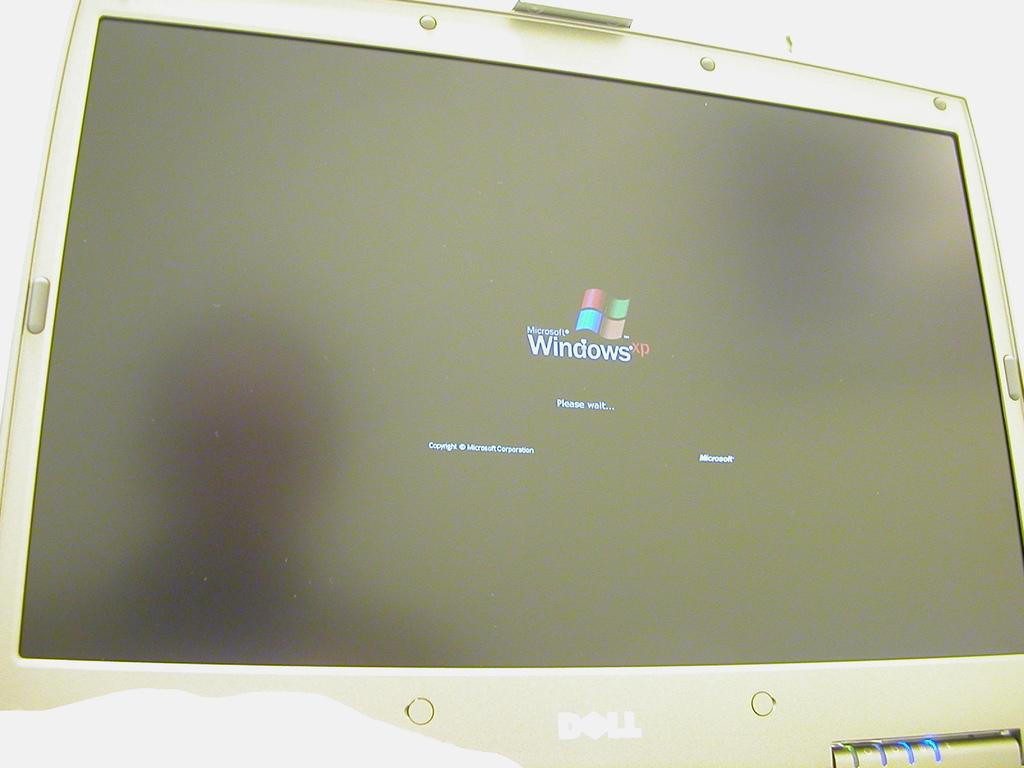What electronic device is visible in the image? There is a monitor in the image. What is displayed on the monitor screen? There is an image and text on the monitor screen. Is there any identifying information on the image displayed on the monitor? Yes, there is a name at the bottom of the image on the monitor. What type of band is performing on the shelf in the image? There is no band or shelf present in the image; it only features a monitor with an image and text on the screen. 